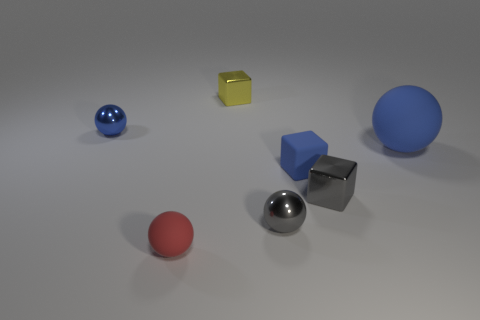What is the shape of the yellow metallic object on the right side of the metallic sphere behind the big thing? The yellow metallic object to the right of the large metallic sphere appears to be a cube, a six-faced geometric figure with each side being a square of equal size. 